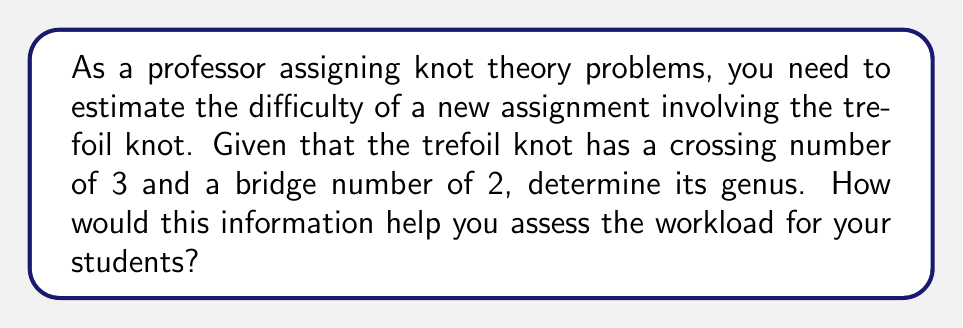Solve this math problem. To determine the genus of the trefoil knot and assess its difficulty, we'll follow these steps:

1. Recall the relationship between crossing number (c), bridge number (b), and genus (g) for alternating knots:

   $$2g = c - 2b + 2$$

2. We're given that for the trefoil knot:
   - Crossing number (c) = 3
   - Bridge number (b) = 2

3. Substitute these values into the equation:

   $$2g = 3 - 2(2) + 2$$

4. Simplify:
   $$2g = 3 - 4 + 2 = 1$$

5. Solve for g:
   $$g = \frac{1}{2}$$

6. Since genus must be a non-negative integer, we round up:
   $$g = 1$$

7. Interpreting the result:
   - The genus of a knot is a measure of its complexity.
   - A genus of 1 indicates that the trefoil knot is the simplest non-trivial knot.
   - This suggests that the assignment is at an introductory level in knot theory.

8. Assessing workload:
   - The low genus indicates that this problem is suitable for beginners.
   - Students should be able to handle this assignment without excessive difficulty.
   - You may consider this as a foundational problem in a series of increasingly complex knot theory assignments.
Answer: Genus = 1; Indicates an introductory-level assignment with moderate workload. 